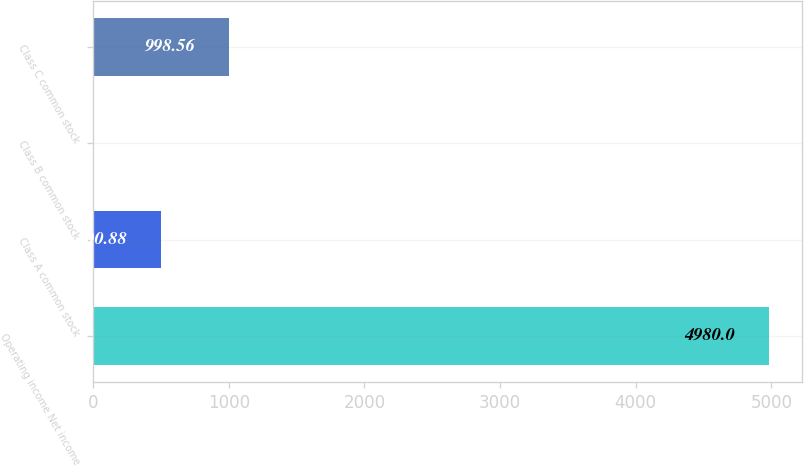Convert chart. <chart><loc_0><loc_0><loc_500><loc_500><bar_chart><fcel>Operating income Net income<fcel>Class A common stock<fcel>Class B common stock<fcel>Class C common stock<nl><fcel>4980<fcel>500.88<fcel>3.2<fcel>998.56<nl></chart> 